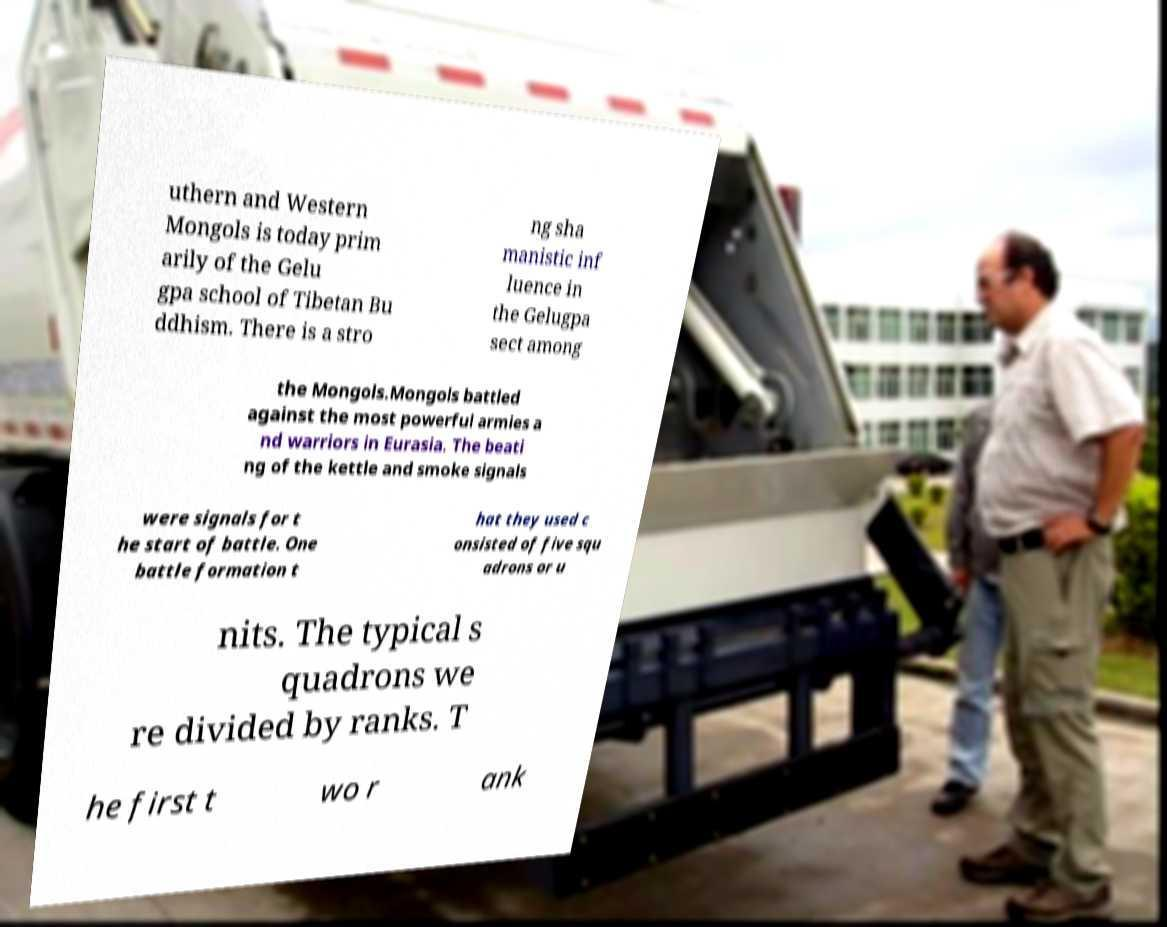Could you assist in decoding the text presented in this image and type it out clearly? uthern and Western Mongols is today prim arily of the Gelu gpa school of Tibetan Bu ddhism. There is a stro ng sha manistic inf luence in the Gelugpa sect among the Mongols.Mongols battled against the most powerful armies a nd warriors in Eurasia. The beati ng of the kettle and smoke signals were signals for t he start of battle. One battle formation t hat they used c onsisted of five squ adrons or u nits. The typical s quadrons we re divided by ranks. T he first t wo r ank 